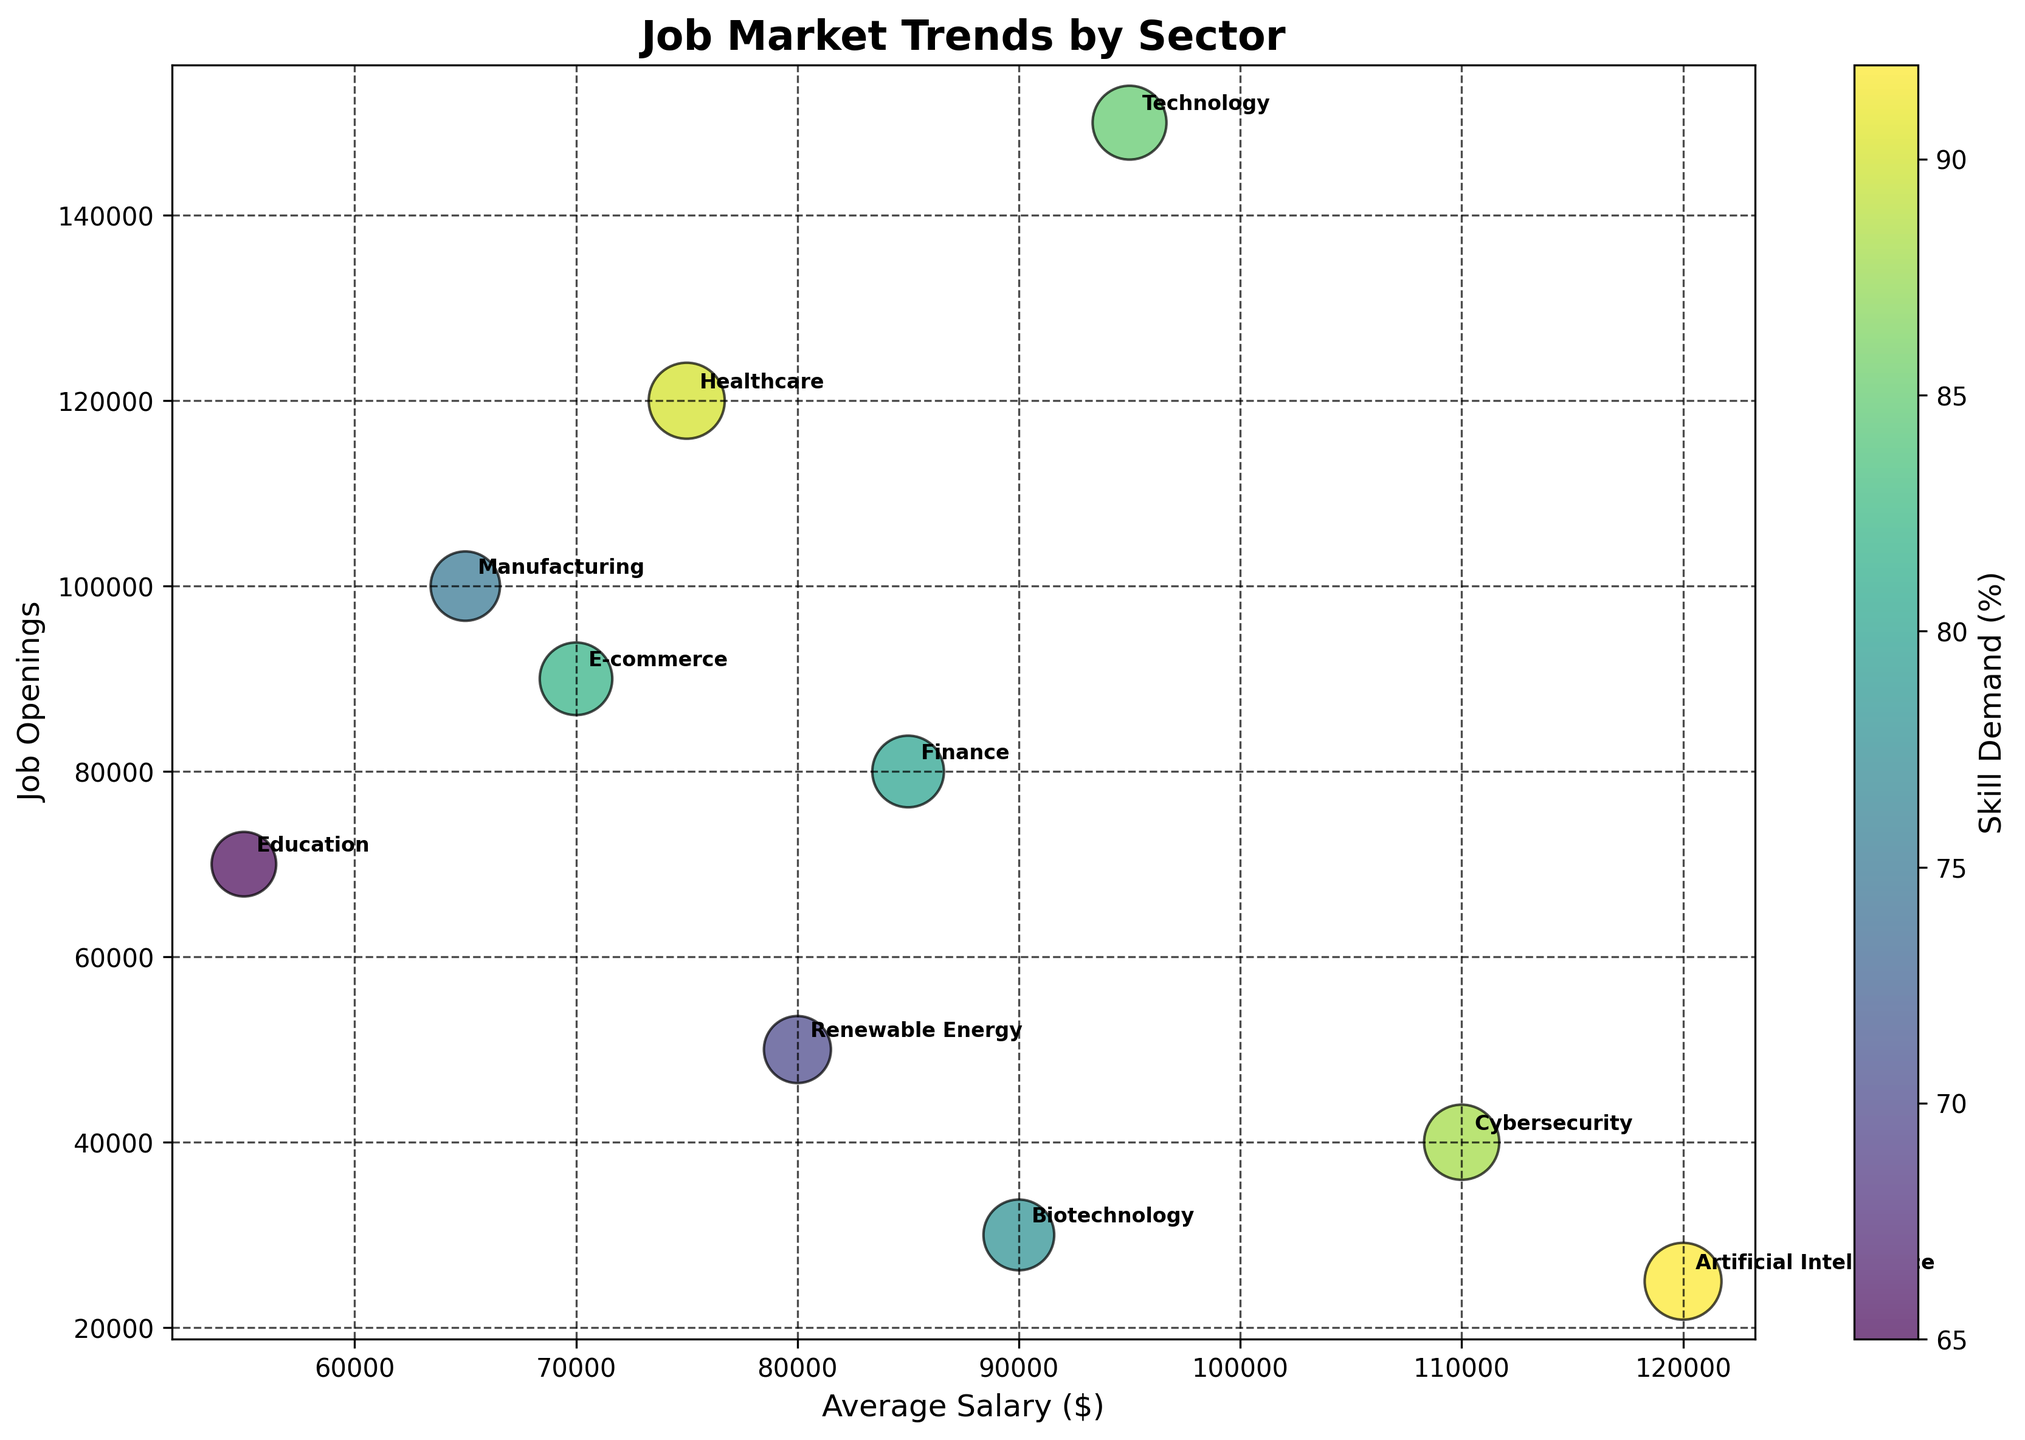What is the title of the figure? The title is generally placed at the top of the figure. In this case, the title is clearly given as 'Job Market Trends by Sector'.
Answer: Job Market Trends by Sector What sectors have the highest and lowest average salaries? To find the highest and lowest average salaries, scan the x-axis (Average Salary) for the bubbles positioned furthest to the right and left, respectively. The sector with the highest is Artificial Intelligence, and the lowest is Education.
Answer: Artificial Intelligence, Education Which sector has the highest skill demand, and what is its requirement? The color bar represents skill demand, and the bubble for the sector with the deepest color towards the high end indicates the highest skill demand. Examining the chart, Artificial Intelligence shows the deepest color with a skill demand of 92%.
Answer: Artificial Intelligence, 92% What is the total number of job openings in Technology and Healthcare? Look at the y-axis (Job Openings) for the Technology and Healthcare bubbles and sum these two values. Technology has 150,000 and Healthcare has 120,000 job openings. Therefore, the total is 150,000 + 120,000 = 270,000.
Answer: 270,000 Which sector has a higher average salary: Finance or Renewable Energy? Compare the positions of the Finance and Renewable Energy bubbles along the x-axis (Average Salary). Finance's bubble is further to the right, indicating a higher average salary compared to Renewable Energy.
Answer: Finance What is the average skill demand across all sectors? Determine the skill demand for each sector from the color bar and descriptions, then sum these percentages and divide by the number of sectors (10). (85 + 90 + 80 + 75 + 70 + 82 + 65 + 88 + 78 + 92) / 10 = 80.5%.
Answer: 80.5% Which sector has the smallest number of job openings, and what is that number? Identify the bubble positioned lowest along the y-axis (Job Openings). The sector with the smallest number of job openings is Artificial Intelligence, with 25,000 openings.
Answer: Artificial Intelligence, 25,000 Compare the job openings and skill demand for Biotechnology and Cybersecurity. Check the y-axis positions (Job Openings) and the color depth (Skill Demand). Biotechnology has 30,000 openings and a skill demand of 78%, while Cybersecurity has 40,000 openings and a skill demand of 88%. So, Cybersecurity has more job openings and a higher skill demand.
Answer: Cybersecurity has more job openings and higher skill demand How does the average salary in E-commerce compare to Healthcare? Compare the E-commerce and Healthcare bubbles along the x-axis (Average Salary). The Healthcare bubble is further right, indicating a higher average salary than E-commerce.
Answer: Healthcare 